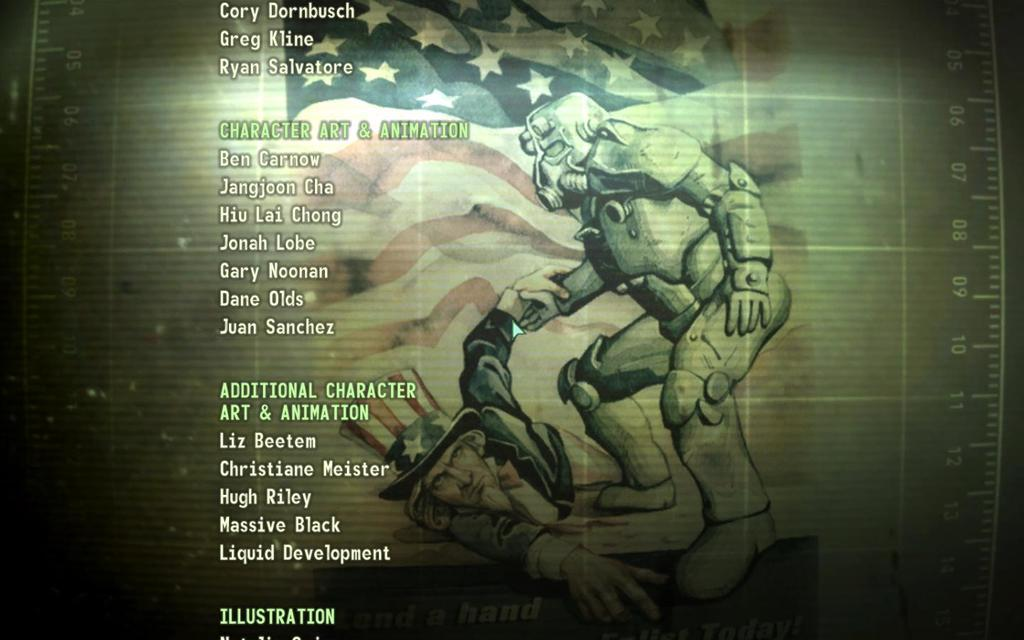<image>
Relay a brief, clear account of the picture shown. The credits screen is playing and shows that Ben Carnow worked on character art and animation. 